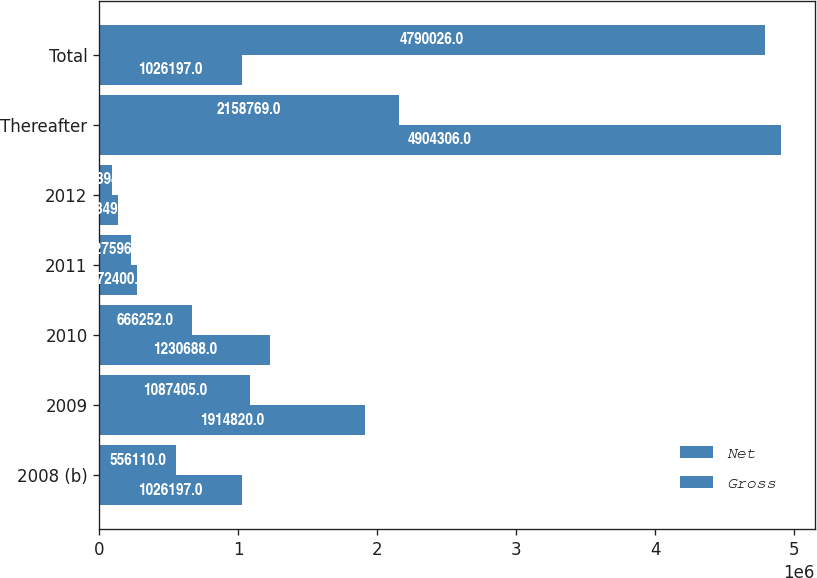Convert chart. <chart><loc_0><loc_0><loc_500><loc_500><stacked_bar_chart><ecel><fcel>2008 (b)<fcel>2009<fcel>2010<fcel>2011<fcel>2012<fcel>Thereafter<fcel>Total<nl><fcel>Net<fcel>1.0262e+06<fcel>1.91482e+06<fcel>1.23069e+06<fcel>272400<fcel>133499<fcel>4.90431e+06<fcel>1.0262e+06<nl><fcel>Gross<fcel>556110<fcel>1.0874e+06<fcel>666252<fcel>227596<fcel>93894<fcel>2.15877e+06<fcel>4.79003e+06<nl></chart> 